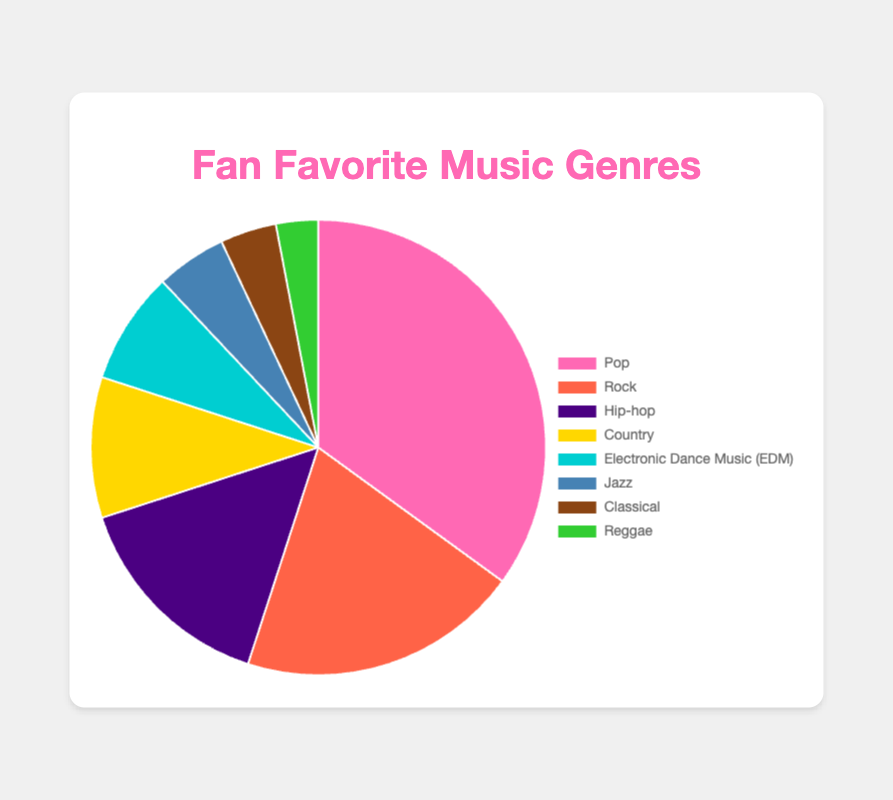What genre has the highest percentage of fan favorites? The genre that occupies the largest portion of the pie chart represents the highest percentage of fan favorites. The largest slice is labeled "Pop" with 35%.
Answer: Pop Which genre has the smallest percentage of fan favorites? The genre with the smallest portion in the pie chart represents the smallest percentage of fan favorites. The smallest slice is labeled "Reggae" with 3%.
Answer: Reggae How much greater is the percentage of Pop fans compared to Hip-hop fans? Subtract the percentage of Hip-hop fans from the percentage of Pop fans: 35% - 15% = 20%.
Answer: 20% If we combine the fans of Jazz and Classical music, what is their total percentage? Add the percentages of fans who favor Jazz and Classical music: 5% + 4% = 9%.
Answer: 9% Which three genres together account for more than half of the fan favorites? To find the three genres together that account for more than 50%, add the percentages of the largest slices until the sum exceeds 50%. Pop (35%) + Rock (20%) + Hip-hop (15%) = 70%, which is more than half.
Answer: Pop, Rock, Hip-hop How does the percentage of Country fans compare to that of EDM fans? The percentage of Country fans is labeled as 10% and that of EDM fans is labeled as 8%. 10% is greater than 8%.
Answer: Country fans are more than EDM fans What is the combined percentage of fans who favor genres other than Pop and Rock? Subtract the sum of the percentages of Pop and Rock fans from 100%: 100% - (35% + 20%) = 45%.
Answer: 45% What color is used to represent Jazz in the pie chart? The color used to represent Jazz can be identified by looking at the segment labeled "Jazz". The segment for Jazz is colored in blue.
Answer: Blue How many genres have a percentage of fan favorites less than 10%? Count the labels with percentages less than 10%. They are: EDM (8%), Jazz (5%), Classical (4%), and Reggae (3%). So, there are 4 genres.
Answer: 4 Which slices in the pie chart appear adjacent to the Pop slice? By inspecting the layout of the pie chart, the slices to the immediate left and right of the Pop slice are Rock and Reggae.
Answer: Rock, Reggae 